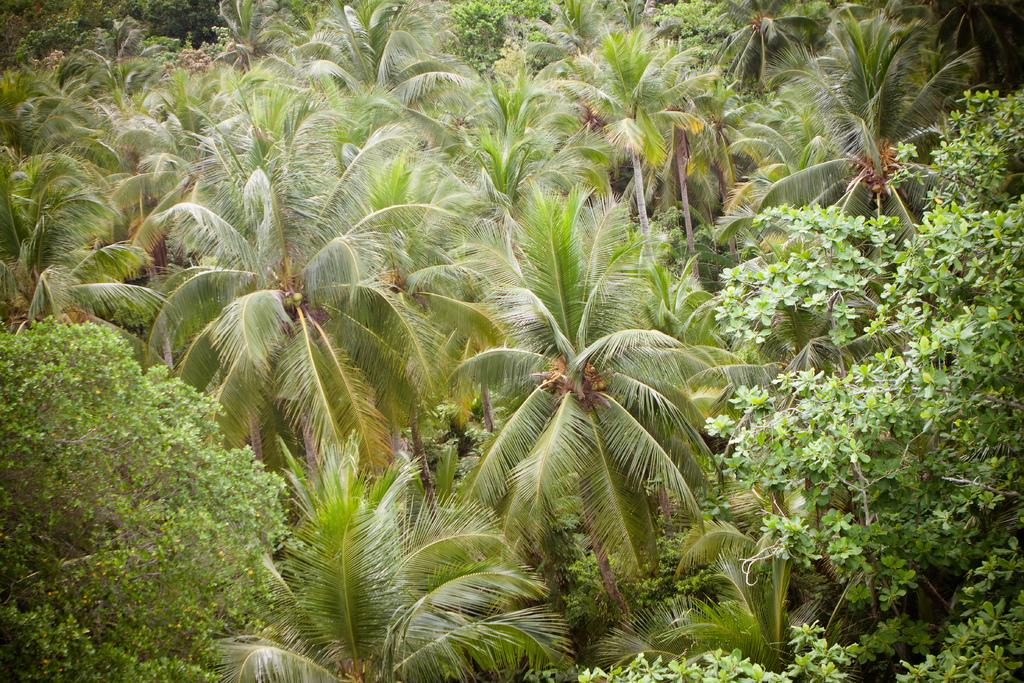What type of vegetation is present in the image? There is a group of trees in the image. What degree does the grandmother have in the image? There is no mention of a grandmother or any degrees in the image; it only features a group of trees. 